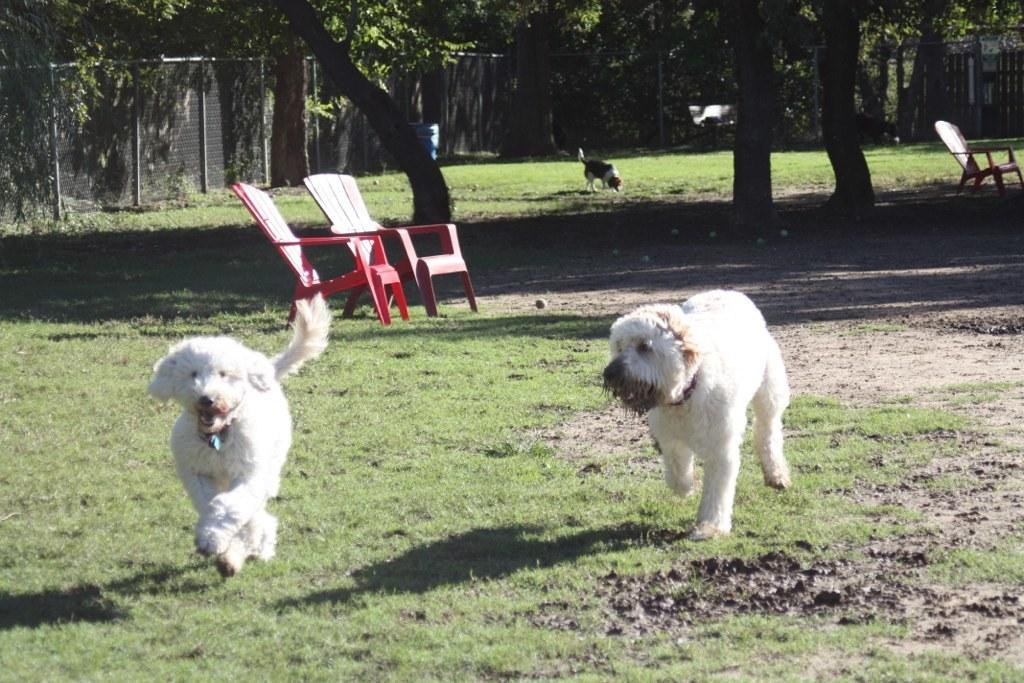Could you give a brief overview of what you see in this image? In this picture we can see two dogs running on a grass and in background we can see two chairs, one more dog, tree, fence and here is the chair. 